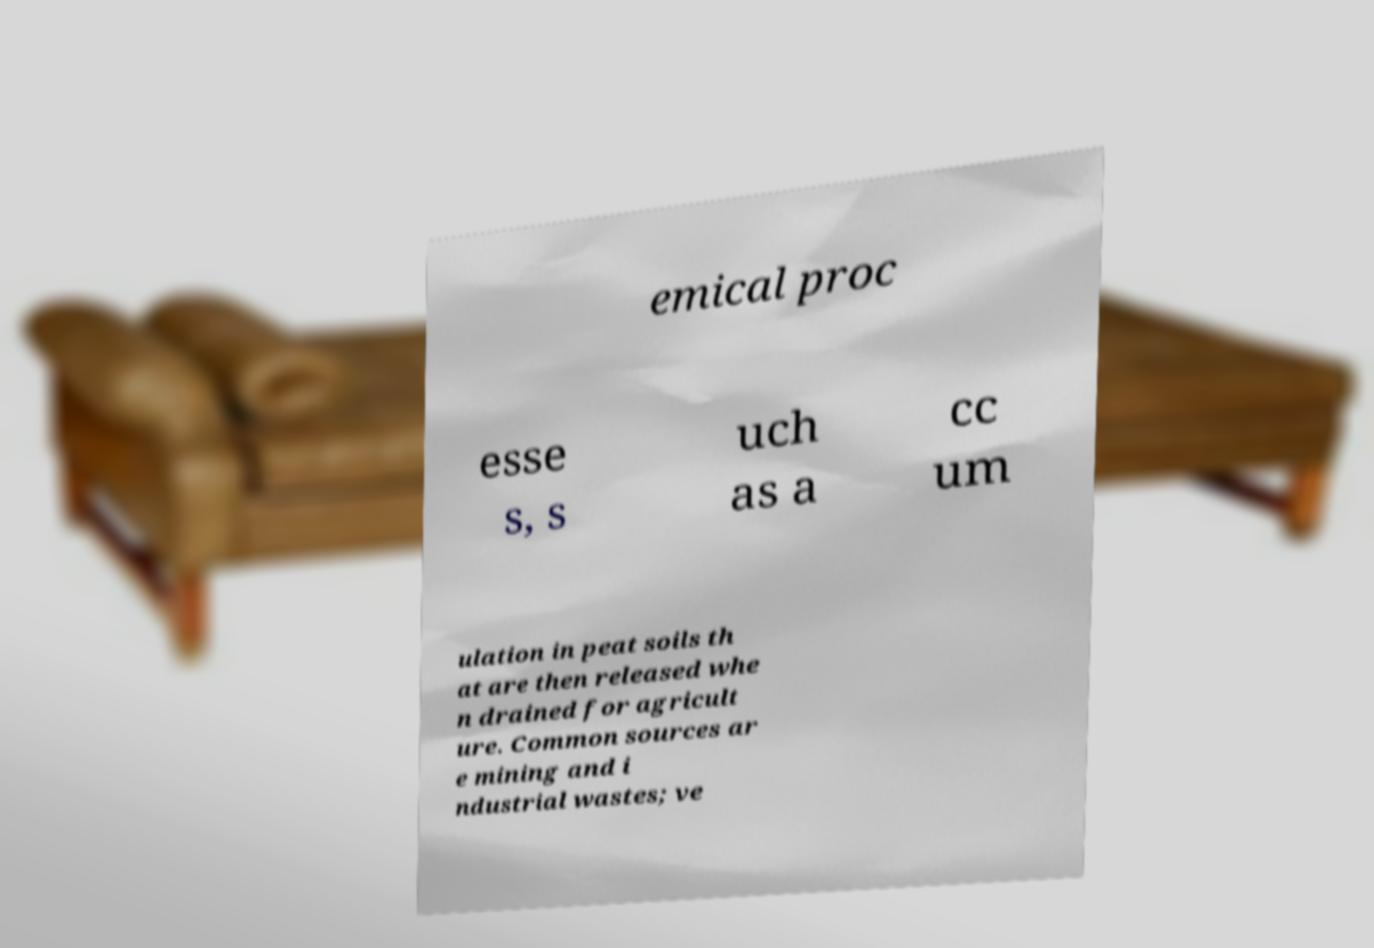For documentation purposes, I need the text within this image transcribed. Could you provide that? emical proc esse s, s uch as a cc um ulation in peat soils th at are then released whe n drained for agricult ure. Common sources ar e mining and i ndustrial wastes; ve 